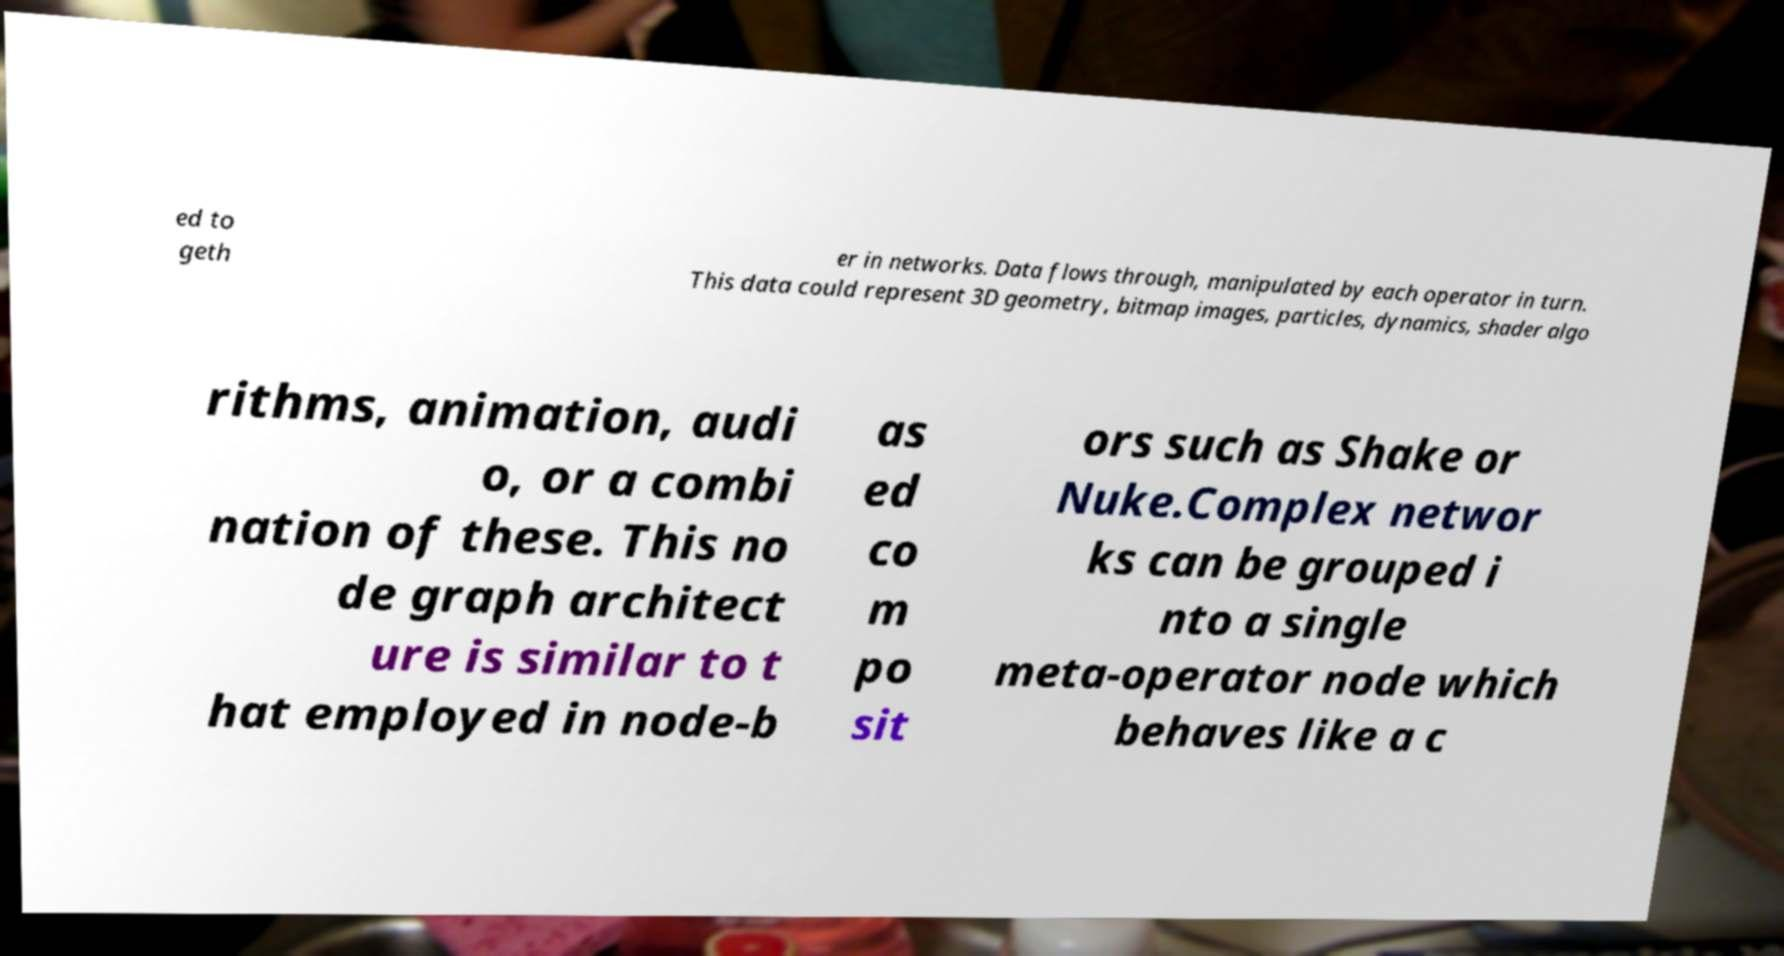I need the written content from this picture converted into text. Can you do that? ed to geth er in networks. Data flows through, manipulated by each operator in turn. This data could represent 3D geometry, bitmap images, particles, dynamics, shader algo rithms, animation, audi o, or a combi nation of these. This no de graph architect ure is similar to t hat employed in node-b as ed co m po sit ors such as Shake or Nuke.Complex networ ks can be grouped i nto a single meta-operator node which behaves like a c 